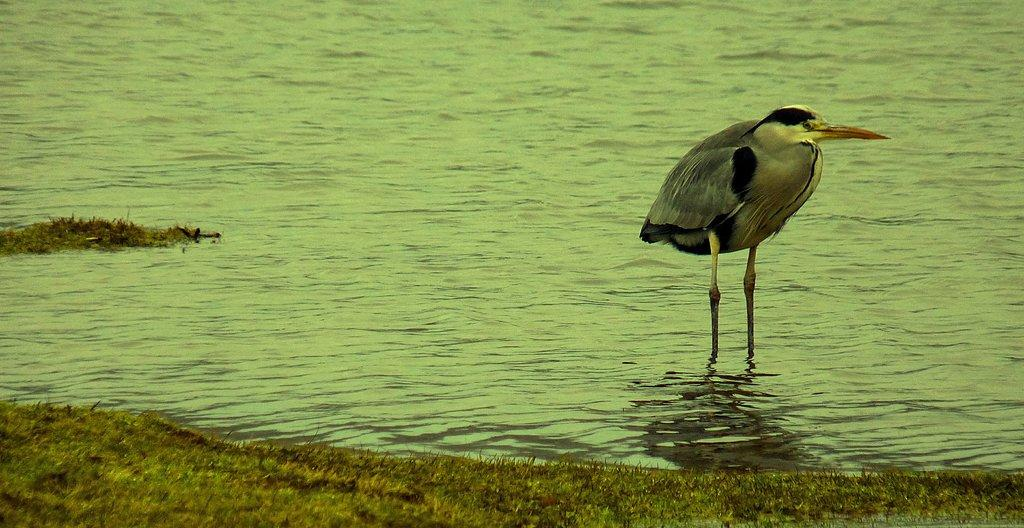What type of animal can be seen in the image? There is a bird in the image. Where is the bird located in the image? The bird is standing on the right side of the image. What is the bird standing on? The bird is standing in the water. What type of surface is visible in the image? There is grass visible on the floor in the image. What type of food is the bird holding in its mouth in the image? There is no food visible in the bird's mouth in the image. Where is the bird's home located in the image? There is no information about the bird's home in the image. 